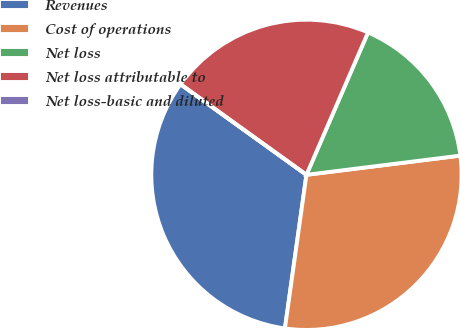Convert chart to OTSL. <chart><loc_0><loc_0><loc_500><loc_500><pie_chart><fcel>Revenues<fcel>Cost of operations<fcel>Net loss<fcel>Net loss attributable to<fcel>Net loss-basic and diluted<nl><fcel>32.71%<fcel>29.19%<fcel>16.53%<fcel>21.57%<fcel>0.0%<nl></chart> 